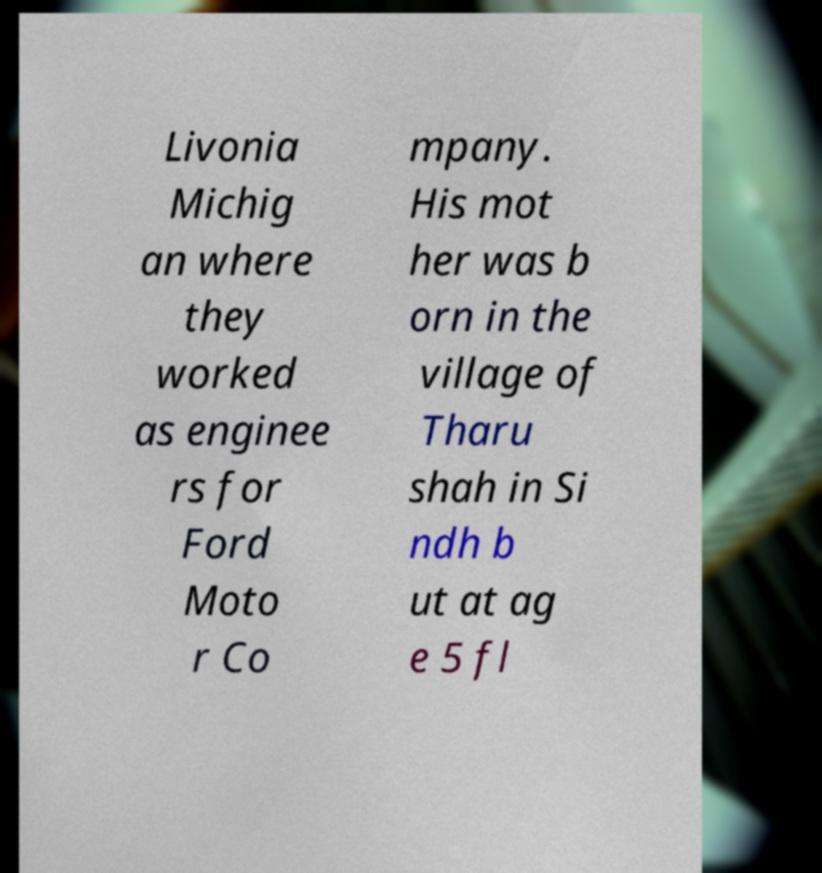Can you read and provide the text displayed in the image?This photo seems to have some interesting text. Can you extract and type it out for me? Livonia Michig an where they worked as enginee rs for Ford Moto r Co mpany. His mot her was b orn in the village of Tharu shah in Si ndh b ut at ag e 5 fl 